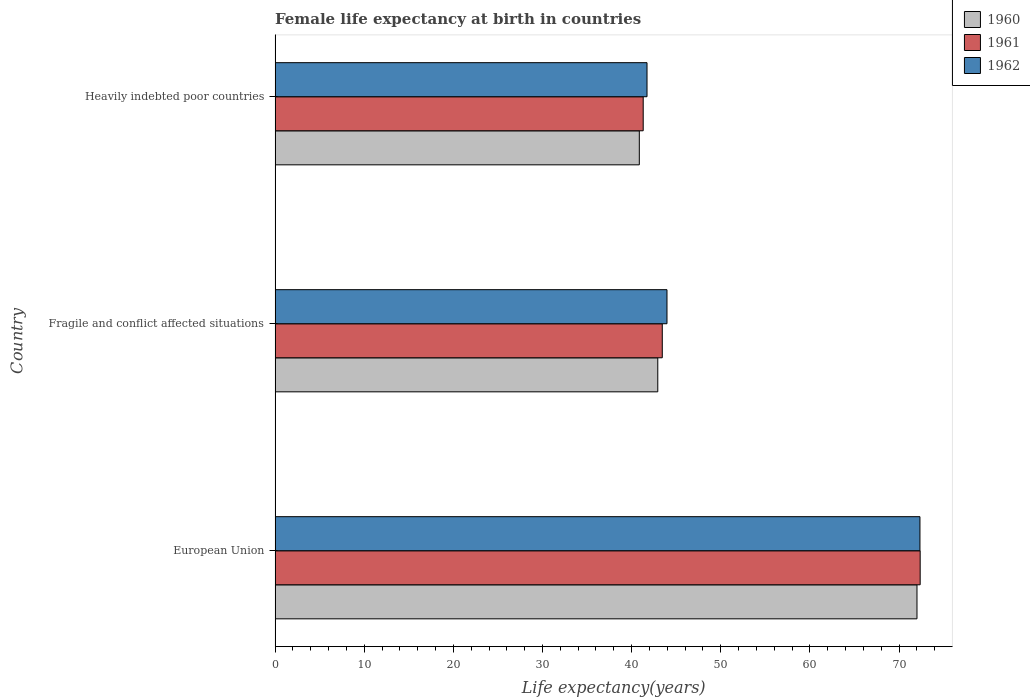Are the number of bars per tick equal to the number of legend labels?
Ensure brevity in your answer.  Yes. How many bars are there on the 2nd tick from the top?
Make the answer very short. 3. How many bars are there on the 1st tick from the bottom?
Offer a very short reply. 3. What is the label of the 2nd group of bars from the top?
Keep it short and to the point. Fragile and conflict affected situations. In how many cases, is the number of bars for a given country not equal to the number of legend labels?
Make the answer very short. 0. What is the female life expectancy at birth in 1960 in Heavily indebted poor countries?
Your response must be concise. 40.86. Across all countries, what is the maximum female life expectancy at birth in 1960?
Offer a very short reply. 72.02. Across all countries, what is the minimum female life expectancy at birth in 1961?
Provide a succinct answer. 41.3. In which country was the female life expectancy at birth in 1962 minimum?
Ensure brevity in your answer.  Heavily indebted poor countries. What is the total female life expectancy at birth in 1961 in the graph?
Make the answer very short. 157.11. What is the difference between the female life expectancy at birth in 1960 in European Union and that in Heavily indebted poor countries?
Offer a very short reply. 31.15. What is the difference between the female life expectancy at birth in 1962 in European Union and the female life expectancy at birth in 1960 in Fragile and conflict affected situations?
Provide a short and direct response. 29.41. What is the average female life expectancy at birth in 1962 per country?
Your answer should be compact. 52.68. What is the difference between the female life expectancy at birth in 1960 and female life expectancy at birth in 1962 in Heavily indebted poor countries?
Your answer should be very brief. -0.87. What is the ratio of the female life expectancy at birth in 1961 in European Union to that in Heavily indebted poor countries?
Keep it short and to the point. 1.75. Is the female life expectancy at birth in 1960 in European Union less than that in Heavily indebted poor countries?
Offer a very short reply. No. What is the difference between the highest and the second highest female life expectancy at birth in 1960?
Give a very brief answer. 29.08. What is the difference between the highest and the lowest female life expectancy at birth in 1962?
Your response must be concise. 30.62. What does the 2nd bar from the top in European Union represents?
Ensure brevity in your answer.  1961. What does the 3rd bar from the bottom in Heavily indebted poor countries represents?
Keep it short and to the point. 1962. Is it the case that in every country, the sum of the female life expectancy at birth in 1962 and female life expectancy at birth in 1961 is greater than the female life expectancy at birth in 1960?
Offer a terse response. Yes. Are all the bars in the graph horizontal?
Offer a very short reply. Yes. How many countries are there in the graph?
Your answer should be very brief. 3. What is the difference between two consecutive major ticks on the X-axis?
Offer a terse response. 10. Are the values on the major ticks of X-axis written in scientific E-notation?
Your answer should be compact. No. What is the title of the graph?
Your answer should be very brief. Female life expectancy at birth in countries. Does "1964" appear as one of the legend labels in the graph?
Provide a succinct answer. No. What is the label or title of the X-axis?
Keep it short and to the point. Life expectancy(years). What is the Life expectancy(years) in 1960 in European Union?
Your answer should be compact. 72.02. What is the Life expectancy(years) of 1961 in European Union?
Keep it short and to the point. 72.37. What is the Life expectancy(years) of 1962 in European Union?
Provide a short and direct response. 72.35. What is the Life expectancy(years) of 1960 in Fragile and conflict affected situations?
Your answer should be compact. 42.94. What is the Life expectancy(years) of 1961 in Fragile and conflict affected situations?
Ensure brevity in your answer.  43.44. What is the Life expectancy(years) in 1962 in Fragile and conflict affected situations?
Keep it short and to the point. 43.97. What is the Life expectancy(years) of 1960 in Heavily indebted poor countries?
Your response must be concise. 40.86. What is the Life expectancy(years) of 1961 in Heavily indebted poor countries?
Offer a very short reply. 41.3. What is the Life expectancy(years) in 1962 in Heavily indebted poor countries?
Keep it short and to the point. 41.73. Across all countries, what is the maximum Life expectancy(years) of 1960?
Give a very brief answer. 72.02. Across all countries, what is the maximum Life expectancy(years) of 1961?
Keep it short and to the point. 72.37. Across all countries, what is the maximum Life expectancy(years) in 1962?
Ensure brevity in your answer.  72.35. Across all countries, what is the minimum Life expectancy(years) in 1960?
Provide a short and direct response. 40.86. Across all countries, what is the minimum Life expectancy(years) of 1961?
Offer a very short reply. 41.3. Across all countries, what is the minimum Life expectancy(years) in 1962?
Your answer should be very brief. 41.73. What is the total Life expectancy(years) in 1960 in the graph?
Offer a terse response. 155.81. What is the total Life expectancy(years) of 1961 in the graph?
Ensure brevity in your answer.  157.11. What is the total Life expectancy(years) of 1962 in the graph?
Ensure brevity in your answer.  158.04. What is the difference between the Life expectancy(years) of 1960 in European Union and that in Fragile and conflict affected situations?
Your response must be concise. 29.08. What is the difference between the Life expectancy(years) in 1961 in European Union and that in Fragile and conflict affected situations?
Offer a very short reply. 28.93. What is the difference between the Life expectancy(years) of 1962 in European Union and that in Fragile and conflict affected situations?
Your answer should be very brief. 28.38. What is the difference between the Life expectancy(years) in 1960 in European Union and that in Heavily indebted poor countries?
Provide a succinct answer. 31.15. What is the difference between the Life expectancy(years) of 1961 in European Union and that in Heavily indebted poor countries?
Provide a short and direct response. 31.07. What is the difference between the Life expectancy(years) in 1962 in European Union and that in Heavily indebted poor countries?
Keep it short and to the point. 30.62. What is the difference between the Life expectancy(years) of 1960 in Fragile and conflict affected situations and that in Heavily indebted poor countries?
Your answer should be very brief. 2.07. What is the difference between the Life expectancy(years) in 1961 in Fragile and conflict affected situations and that in Heavily indebted poor countries?
Your response must be concise. 2.14. What is the difference between the Life expectancy(years) of 1962 in Fragile and conflict affected situations and that in Heavily indebted poor countries?
Ensure brevity in your answer.  2.24. What is the difference between the Life expectancy(years) in 1960 in European Union and the Life expectancy(years) in 1961 in Fragile and conflict affected situations?
Make the answer very short. 28.57. What is the difference between the Life expectancy(years) in 1960 in European Union and the Life expectancy(years) in 1962 in Fragile and conflict affected situations?
Make the answer very short. 28.05. What is the difference between the Life expectancy(years) of 1961 in European Union and the Life expectancy(years) of 1962 in Fragile and conflict affected situations?
Provide a short and direct response. 28.41. What is the difference between the Life expectancy(years) in 1960 in European Union and the Life expectancy(years) in 1961 in Heavily indebted poor countries?
Provide a short and direct response. 30.72. What is the difference between the Life expectancy(years) in 1960 in European Union and the Life expectancy(years) in 1962 in Heavily indebted poor countries?
Keep it short and to the point. 30.29. What is the difference between the Life expectancy(years) of 1961 in European Union and the Life expectancy(years) of 1962 in Heavily indebted poor countries?
Your answer should be compact. 30.64. What is the difference between the Life expectancy(years) of 1960 in Fragile and conflict affected situations and the Life expectancy(years) of 1961 in Heavily indebted poor countries?
Provide a succinct answer. 1.64. What is the difference between the Life expectancy(years) in 1960 in Fragile and conflict affected situations and the Life expectancy(years) in 1962 in Heavily indebted poor countries?
Keep it short and to the point. 1.21. What is the difference between the Life expectancy(years) in 1961 in Fragile and conflict affected situations and the Life expectancy(years) in 1962 in Heavily indebted poor countries?
Keep it short and to the point. 1.71. What is the average Life expectancy(years) of 1960 per country?
Provide a succinct answer. 51.94. What is the average Life expectancy(years) of 1961 per country?
Ensure brevity in your answer.  52.37. What is the average Life expectancy(years) in 1962 per country?
Give a very brief answer. 52.68. What is the difference between the Life expectancy(years) in 1960 and Life expectancy(years) in 1961 in European Union?
Offer a terse response. -0.36. What is the difference between the Life expectancy(years) of 1960 and Life expectancy(years) of 1962 in European Union?
Keep it short and to the point. -0.33. What is the difference between the Life expectancy(years) in 1961 and Life expectancy(years) in 1962 in European Union?
Your answer should be compact. 0.03. What is the difference between the Life expectancy(years) of 1960 and Life expectancy(years) of 1961 in Fragile and conflict affected situations?
Ensure brevity in your answer.  -0.5. What is the difference between the Life expectancy(years) in 1960 and Life expectancy(years) in 1962 in Fragile and conflict affected situations?
Ensure brevity in your answer.  -1.03. What is the difference between the Life expectancy(years) in 1961 and Life expectancy(years) in 1962 in Fragile and conflict affected situations?
Offer a terse response. -0.53. What is the difference between the Life expectancy(years) in 1960 and Life expectancy(years) in 1961 in Heavily indebted poor countries?
Make the answer very short. -0.44. What is the difference between the Life expectancy(years) of 1960 and Life expectancy(years) of 1962 in Heavily indebted poor countries?
Offer a very short reply. -0.87. What is the difference between the Life expectancy(years) in 1961 and Life expectancy(years) in 1962 in Heavily indebted poor countries?
Offer a very short reply. -0.43. What is the ratio of the Life expectancy(years) in 1960 in European Union to that in Fragile and conflict affected situations?
Give a very brief answer. 1.68. What is the ratio of the Life expectancy(years) in 1961 in European Union to that in Fragile and conflict affected situations?
Provide a succinct answer. 1.67. What is the ratio of the Life expectancy(years) in 1962 in European Union to that in Fragile and conflict affected situations?
Offer a terse response. 1.65. What is the ratio of the Life expectancy(years) in 1960 in European Union to that in Heavily indebted poor countries?
Provide a succinct answer. 1.76. What is the ratio of the Life expectancy(years) of 1961 in European Union to that in Heavily indebted poor countries?
Keep it short and to the point. 1.75. What is the ratio of the Life expectancy(years) in 1962 in European Union to that in Heavily indebted poor countries?
Provide a succinct answer. 1.73. What is the ratio of the Life expectancy(years) of 1960 in Fragile and conflict affected situations to that in Heavily indebted poor countries?
Provide a succinct answer. 1.05. What is the ratio of the Life expectancy(years) of 1961 in Fragile and conflict affected situations to that in Heavily indebted poor countries?
Provide a short and direct response. 1.05. What is the ratio of the Life expectancy(years) of 1962 in Fragile and conflict affected situations to that in Heavily indebted poor countries?
Provide a short and direct response. 1.05. What is the difference between the highest and the second highest Life expectancy(years) in 1960?
Offer a very short reply. 29.08. What is the difference between the highest and the second highest Life expectancy(years) in 1961?
Your answer should be very brief. 28.93. What is the difference between the highest and the second highest Life expectancy(years) of 1962?
Give a very brief answer. 28.38. What is the difference between the highest and the lowest Life expectancy(years) in 1960?
Your answer should be compact. 31.15. What is the difference between the highest and the lowest Life expectancy(years) in 1961?
Your answer should be compact. 31.07. What is the difference between the highest and the lowest Life expectancy(years) of 1962?
Provide a short and direct response. 30.62. 